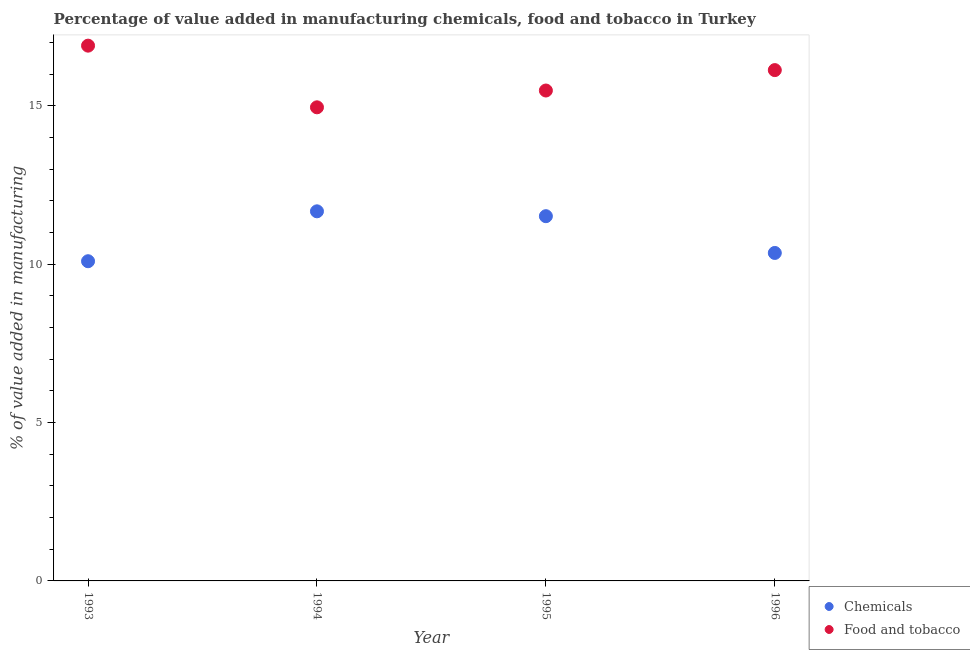How many different coloured dotlines are there?
Provide a short and direct response. 2. What is the value added by manufacturing food and tobacco in 1995?
Ensure brevity in your answer.  15.48. Across all years, what is the maximum value added by manufacturing food and tobacco?
Your response must be concise. 16.9. Across all years, what is the minimum value added by manufacturing food and tobacco?
Provide a short and direct response. 14.95. What is the total value added by manufacturing food and tobacco in the graph?
Make the answer very short. 63.45. What is the difference between the value added by manufacturing food and tobacco in 1993 and that in 1994?
Your answer should be very brief. 1.95. What is the difference between the value added by manufacturing food and tobacco in 1994 and the value added by  manufacturing chemicals in 1995?
Offer a terse response. 3.44. What is the average value added by  manufacturing chemicals per year?
Your answer should be very brief. 10.91. In the year 1995, what is the difference between the value added by manufacturing food and tobacco and value added by  manufacturing chemicals?
Your answer should be compact. 3.97. In how many years, is the value added by manufacturing food and tobacco greater than 3 %?
Make the answer very short. 4. What is the ratio of the value added by  manufacturing chemicals in 1995 to that in 1996?
Your answer should be compact. 1.11. What is the difference between the highest and the second highest value added by manufacturing food and tobacco?
Your answer should be very brief. 0.77. What is the difference between the highest and the lowest value added by  manufacturing chemicals?
Your response must be concise. 1.58. Is the sum of the value added by  manufacturing chemicals in 1993 and 1994 greater than the maximum value added by manufacturing food and tobacco across all years?
Ensure brevity in your answer.  Yes. Does the value added by manufacturing food and tobacco monotonically increase over the years?
Give a very brief answer. No. Is the value added by  manufacturing chemicals strictly greater than the value added by manufacturing food and tobacco over the years?
Your answer should be very brief. No. How many years are there in the graph?
Your answer should be compact. 4. What is the difference between two consecutive major ticks on the Y-axis?
Offer a very short reply. 5. How are the legend labels stacked?
Offer a very short reply. Vertical. What is the title of the graph?
Offer a terse response. Percentage of value added in manufacturing chemicals, food and tobacco in Turkey. Does "Male" appear as one of the legend labels in the graph?
Give a very brief answer. No. What is the label or title of the X-axis?
Keep it short and to the point. Year. What is the label or title of the Y-axis?
Give a very brief answer. % of value added in manufacturing. What is the % of value added in manufacturing of Chemicals in 1993?
Provide a succinct answer. 10.09. What is the % of value added in manufacturing of Food and tobacco in 1993?
Offer a terse response. 16.9. What is the % of value added in manufacturing in Chemicals in 1994?
Give a very brief answer. 11.67. What is the % of value added in manufacturing of Food and tobacco in 1994?
Offer a terse response. 14.95. What is the % of value added in manufacturing in Chemicals in 1995?
Offer a terse response. 11.51. What is the % of value added in manufacturing of Food and tobacco in 1995?
Keep it short and to the point. 15.48. What is the % of value added in manufacturing of Chemicals in 1996?
Your answer should be very brief. 10.35. What is the % of value added in manufacturing in Food and tobacco in 1996?
Give a very brief answer. 16.12. Across all years, what is the maximum % of value added in manufacturing in Chemicals?
Keep it short and to the point. 11.67. Across all years, what is the maximum % of value added in manufacturing in Food and tobacco?
Keep it short and to the point. 16.9. Across all years, what is the minimum % of value added in manufacturing in Chemicals?
Give a very brief answer. 10.09. Across all years, what is the minimum % of value added in manufacturing of Food and tobacco?
Ensure brevity in your answer.  14.95. What is the total % of value added in manufacturing in Chemicals in the graph?
Keep it short and to the point. 43.63. What is the total % of value added in manufacturing of Food and tobacco in the graph?
Provide a short and direct response. 63.45. What is the difference between the % of value added in manufacturing of Chemicals in 1993 and that in 1994?
Give a very brief answer. -1.58. What is the difference between the % of value added in manufacturing of Food and tobacco in 1993 and that in 1994?
Give a very brief answer. 1.95. What is the difference between the % of value added in manufacturing in Chemicals in 1993 and that in 1995?
Your response must be concise. -1.42. What is the difference between the % of value added in manufacturing in Food and tobacco in 1993 and that in 1995?
Provide a succinct answer. 1.42. What is the difference between the % of value added in manufacturing of Chemicals in 1993 and that in 1996?
Provide a succinct answer. -0.26. What is the difference between the % of value added in manufacturing in Food and tobacco in 1993 and that in 1996?
Provide a succinct answer. 0.77. What is the difference between the % of value added in manufacturing in Chemicals in 1994 and that in 1995?
Your response must be concise. 0.15. What is the difference between the % of value added in manufacturing of Food and tobacco in 1994 and that in 1995?
Give a very brief answer. -0.53. What is the difference between the % of value added in manufacturing of Chemicals in 1994 and that in 1996?
Make the answer very short. 1.31. What is the difference between the % of value added in manufacturing in Food and tobacco in 1994 and that in 1996?
Keep it short and to the point. -1.17. What is the difference between the % of value added in manufacturing of Chemicals in 1995 and that in 1996?
Make the answer very short. 1.16. What is the difference between the % of value added in manufacturing in Food and tobacco in 1995 and that in 1996?
Your response must be concise. -0.64. What is the difference between the % of value added in manufacturing of Chemicals in 1993 and the % of value added in manufacturing of Food and tobacco in 1994?
Provide a short and direct response. -4.86. What is the difference between the % of value added in manufacturing of Chemicals in 1993 and the % of value added in manufacturing of Food and tobacco in 1995?
Offer a terse response. -5.39. What is the difference between the % of value added in manufacturing of Chemicals in 1993 and the % of value added in manufacturing of Food and tobacco in 1996?
Your answer should be compact. -6.03. What is the difference between the % of value added in manufacturing of Chemicals in 1994 and the % of value added in manufacturing of Food and tobacco in 1995?
Offer a very short reply. -3.81. What is the difference between the % of value added in manufacturing in Chemicals in 1994 and the % of value added in manufacturing in Food and tobacco in 1996?
Make the answer very short. -4.46. What is the difference between the % of value added in manufacturing of Chemicals in 1995 and the % of value added in manufacturing of Food and tobacco in 1996?
Ensure brevity in your answer.  -4.61. What is the average % of value added in manufacturing in Chemicals per year?
Keep it short and to the point. 10.91. What is the average % of value added in manufacturing in Food and tobacco per year?
Offer a very short reply. 15.86. In the year 1993, what is the difference between the % of value added in manufacturing in Chemicals and % of value added in manufacturing in Food and tobacco?
Offer a very short reply. -6.8. In the year 1994, what is the difference between the % of value added in manufacturing of Chemicals and % of value added in manufacturing of Food and tobacco?
Your answer should be very brief. -3.28. In the year 1995, what is the difference between the % of value added in manufacturing in Chemicals and % of value added in manufacturing in Food and tobacco?
Your response must be concise. -3.97. In the year 1996, what is the difference between the % of value added in manufacturing of Chemicals and % of value added in manufacturing of Food and tobacco?
Keep it short and to the point. -5.77. What is the ratio of the % of value added in manufacturing in Chemicals in 1993 to that in 1994?
Provide a succinct answer. 0.86. What is the ratio of the % of value added in manufacturing in Food and tobacco in 1993 to that in 1994?
Your answer should be compact. 1.13. What is the ratio of the % of value added in manufacturing in Chemicals in 1993 to that in 1995?
Offer a terse response. 0.88. What is the ratio of the % of value added in manufacturing of Food and tobacco in 1993 to that in 1995?
Provide a succinct answer. 1.09. What is the ratio of the % of value added in manufacturing in Chemicals in 1993 to that in 1996?
Ensure brevity in your answer.  0.97. What is the ratio of the % of value added in manufacturing in Food and tobacco in 1993 to that in 1996?
Make the answer very short. 1.05. What is the ratio of the % of value added in manufacturing in Chemicals in 1994 to that in 1995?
Offer a very short reply. 1.01. What is the ratio of the % of value added in manufacturing of Food and tobacco in 1994 to that in 1995?
Your response must be concise. 0.97. What is the ratio of the % of value added in manufacturing of Chemicals in 1994 to that in 1996?
Your answer should be compact. 1.13. What is the ratio of the % of value added in manufacturing in Food and tobacco in 1994 to that in 1996?
Your answer should be compact. 0.93. What is the ratio of the % of value added in manufacturing in Chemicals in 1995 to that in 1996?
Your answer should be compact. 1.11. What is the ratio of the % of value added in manufacturing of Food and tobacco in 1995 to that in 1996?
Offer a terse response. 0.96. What is the difference between the highest and the second highest % of value added in manufacturing in Chemicals?
Offer a terse response. 0.15. What is the difference between the highest and the second highest % of value added in manufacturing of Food and tobacco?
Provide a succinct answer. 0.77. What is the difference between the highest and the lowest % of value added in manufacturing in Chemicals?
Offer a very short reply. 1.58. What is the difference between the highest and the lowest % of value added in manufacturing of Food and tobacco?
Your answer should be very brief. 1.95. 